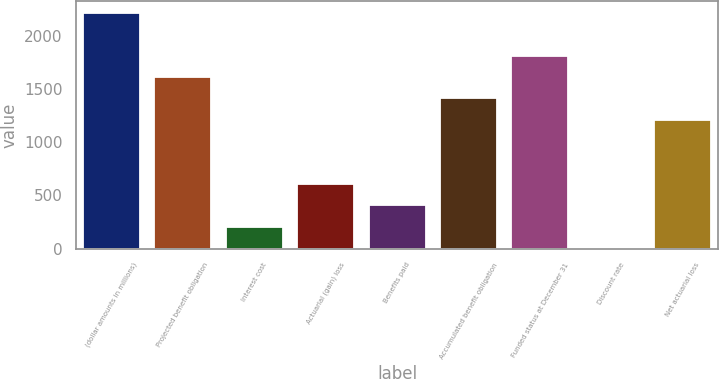Convert chart to OTSL. <chart><loc_0><loc_0><loc_500><loc_500><bar_chart><fcel>(dollar amounts in millions)<fcel>Projected benefit obligation<fcel>Interest cost<fcel>Actuarial (gain) loss<fcel>Benefits paid<fcel>Accumulated benefit obligation<fcel>Funded status at December 31<fcel>Discount rate<fcel>Net actuarial loss<nl><fcel>2213.75<fcel>1611.41<fcel>205.95<fcel>607.51<fcel>406.73<fcel>1410.63<fcel>1812.19<fcel>5.17<fcel>1209.85<nl></chart> 